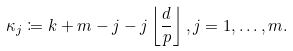Convert formula to latex. <formula><loc_0><loc_0><loc_500><loc_500>\kappa _ { j } \coloneqq k + m - j - j \left \lfloor \frac { d } { p } \right \rfloor , j = 1 , \dots , m .</formula> 